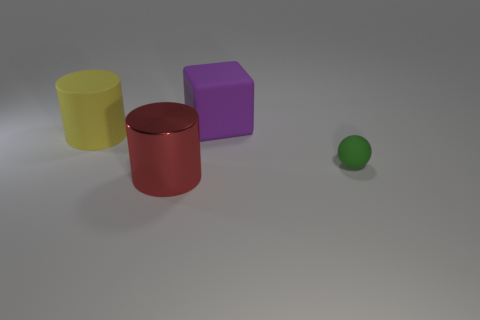Does the object that is right of the purple matte thing have the same material as the yellow cylinder?
Keep it short and to the point. Yes. Are there any matte cylinders behind the large matte object that is in front of the thing behind the big yellow cylinder?
Ensure brevity in your answer.  No. How many spheres are either tiny green objects or big matte objects?
Your answer should be very brief. 1. There is a big thing on the right side of the red metal cylinder; what material is it?
Make the answer very short. Rubber. Does the large matte object that is on the right side of the red cylinder have the same color as the matte object to the left of the large block?
Give a very brief answer. No. How many objects are green cylinders or small green objects?
Keep it short and to the point. 1. What number of other things are there of the same shape as the large yellow thing?
Offer a very short reply. 1. Does the big cylinder in front of the large rubber cylinder have the same material as the thing right of the large cube?
Provide a succinct answer. No. What shape is the matte thing that is left of the green rubber sphere and right of the yellow rubber cylinder?
Offer a terse response. Cube. Are there any other things that have the same material as the red thing?
Offer a very short reply. No. 